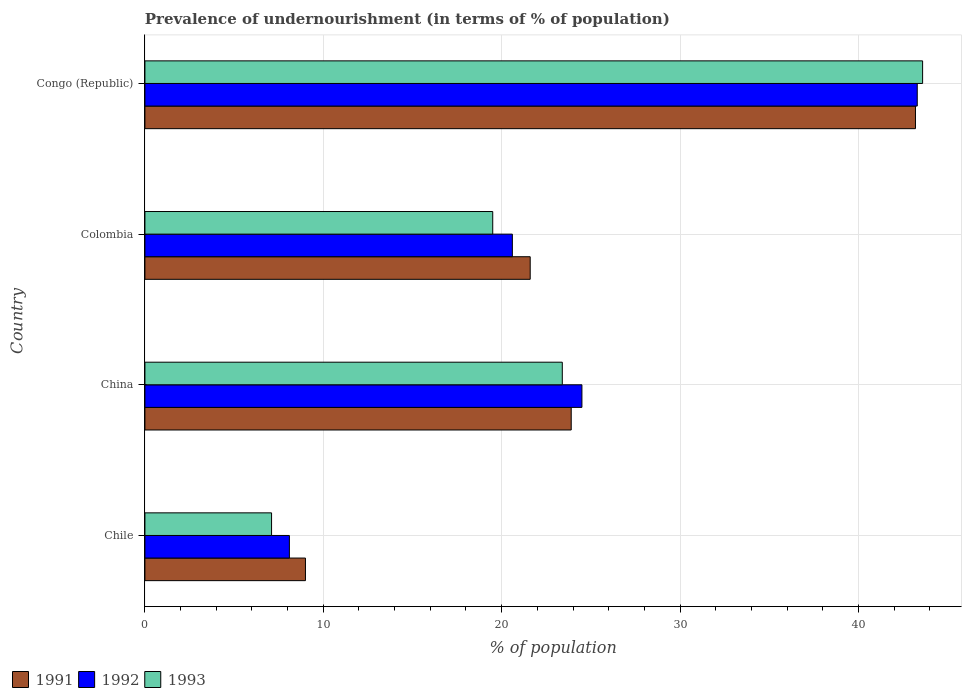How many different coloured bars are there?
Your answer should be very brief. 3. Are the number of bars on each tick of the Y-axis equal?
Provide a short and direct response. Yes. How many bars are there on the 2nd tick from the top?
Keep it short and to the point. 3. In how many cases, is the number of bars for a given country not equal to the number of legend labels?
Keep it short and to the point. 0. What is the percentage of undernourished population in 1993 in China?
Provide a short and direct response. 23.4. Across all countries, what is the maximum percentage of undernourished population in 1992?
Offer a terse response. 43.3. Across all countries, what is the minimum percentage of undernourished population in 1992?
Make the answer very short. 8.1. In which country was the percentage of undernourished population in 1991 maximum?
Your response must be concise. Congo (Republic). What is the total percentage of undernourished population in 1991 in the graph?
Your answer should be compact. 97.7. What is the difference between the percentage of undernourished population in 1993 in China and that in Congo (Republic)?
Provide a succinct answer. -20.2. What is the difference between the percentage of undernourished population in 1991 in China and the percentage of undernourished population in 1993 in Chile?
Provide a succinct answer. 16.8. What is the average percentage of undernourished population in 1993 per country?
Provide a short and direct response. 23.4. What is the difference between the percentage of undernourished population in 1992 and percentage of undernourished population in 1993 in Congo (Republic)?
Provide a succinct answer. -0.3. In how many countries, is the percentage of undernourished population in 1993 greater than 6 %?
Ensure brevity in your answer.  4. What is the ratio of the percentage of undernourished population in 1992 in China to that in Colombia?
Offer a very short reply. 1.19. Is the percentage of undernourished population in 1992 in China less than that in Colombia?
Provide a short and direct response. No. Is the difference between the percentage of undernourished population in 1992 in China and Congo (Republic) greater than the difference between the percentage of undernourished population in 1993 in China and Congo (Republic)?
Give a very brief answer. Yes. What is the difference between the highest and the second highest percentage of undernourished population in 1992?
Make the answer very short. 18.8. What is the difference between the highest and the lowest percentage of undernourished population in 1993?
Ensure brevity in your answer.  36.5. In how many countries, is the percentage of undernourished population in 1991 greater than the average percentage of undernourished population in 1991 taken over all countries?
Provide a short and direct response. 1. What does the 1st bar from the top in Congo (Republic) represents?
Keep it short and to the point. 1993. What does the 3rd bar from the bottom in China represents?
Your response must be concise. 1993. Is it the case that in every country, the sum of the percentage of undernourished population in 1992 and percentage of undernourished population in 1993 is greater than the percentage of undernourished population in 1991?
Your answer should be very brief. Yes. Are all the bars in the graph horizontal?
Make the answer very short. Yes. How many countries are there in the graph?
Ensure brevity in your answer.  4. What is the difference between two consecutive major ticks on the X-axis?
Offer a very short reply. 10. Does the graph contain any zero values?
Provide a short and direct response. No. Does the graph contain grids?
Your answer should be compact. Yes. Where does the legend appear in the graph?
Your response must be concise. Bottom left. How many legend labels are there?
Your answer should be very brief. 3. How are the legend labels stacked?
Make the answer very short. Horizontal. What is the title of the graph?
Provide a succinct answer. Prevalence of undernourishment (in terms of % of population). Does "1961" appear as one of the legend labels in the graph?
Provide a short and direct response. No. What is the label or title of the X-axis?
Give a very brief answer. % of population. What is the % of population in 1991 in Chile?
Your answer should be very brief. 9. What is the % of population of 1992 in Chile?
Give a very brief answer. 8.1. What is the % of population of 1993 in Chile?
Provide a short and direct response. 7.1. What is the % of population in 1991 in China?
Offer a very short reply. 23.9. What is the % of population in 1993 in China?
Offer a terse response. 23.4. What is the % of population of 1991 in Colombia?
Your response must be concise. 21.6. What is the % of population in 1992 in Colombia?
Make the answer very short. 20.6. What is the % of population of 1991 in Congo (Republic)?
Give a very brief answer. 43.2. What is the % of population of 1992 in Congo (Republic)?
Your answer should be very brief. 43.3. What is the % of population in 1993 in Congo (Republic)?
Provide a succinct answer. 43.6. Across all countries, what is the maximum % of population of 1991?
Offer a very short reply. 43.2. Across all countries, what is the maximum % of population in 1992?
Your answer should be very brief. 43.3. Across all countries, what is the maximum % of population of 1993?
Offer a very short reply. 43.6. Across all countries, what is the minimum % of population in 1992?
Keep it short and to the point. 8.1. What is the total % of population of 1991 in the graph?
Provide a succinct answer. 97.7. What is the total % of population of 1992 in the graph?
Your answer should be very brief. 96.5. What is the total % of population in 1993 in the graph?
Your response must be concise. 93.6. What is the difference between the % of population of 1991 in Chile and that in China?
Your response must be concise. -14.9. What is the difference between the % of population in 1992 in Chile and that in China?
Your answer should be compact. -16.4. What is the difference between the % of population in 1993 in Chile and that in China?
Keep it short and to the point. -16.3. What is the difference between the % of population of 1991 in Chile and that in Colombia?
Keep it short and to the point. -12.6. What is the difference between the % of population of 1992 in Chile and that in Colombia?
Provide a short and direct response. -12.5. What is the difference between the % of population of 1993 in Chile and that in Colombia?
Provide a short and direct response. -12.4. What is the difference between the % of population in 1991 in Chile and that in Congo (Republic)?
Provide a succinct answer. -34.2. What is the difference between the % of population of 1992 in Chile and that in Congo (Republic)?
Offer a very short reply. -35.2. What is the difference between the % of population of 1993 in Chile and that in Congo (Republic)?
Your response must be concise. -36.5. What is the difference between the % of population of 1991 in China and that in Colombia?
Offer a very short reply. 2.3. What is the difference between the % of population in 1992 in China and that in Colombia?
Ensure brevity in your answer.  3.9. What is the difference between the % of population of 1993 in China and that in Colombia?
Provide a succinct answer. 3.9. What is the difference between the % of population of 1991 in China and that in Congo (Republic)?
Your answer should be compact. -19.3. What is the difference between the % of population in 1992 in China and that in Congo (Republic)?
Provide a succinct answer. -18.8. What is the difference between the % of population of 1993 in China and that in Congo (Republic)?
Provide a succinct answer. -20.2. What is the difference between the % of population of 1991 in Colombia and that in Congo (Republic)?
Make the answer very short. -21.6. What is the difference between the % of population in 1992 in Colombia and that in Congo (Republic)?
Give a very brief answer. -22.7. What is the difference between the % of population of 1993 in Colombia and that in Congo (Republic)?
Give a very brief answer. -24.1. What is the difference between the % of population of 1991 in Chile and the % of population of 1992 in China?
Your answer should be compact. -15.5. What is the difference between the % of population of 1991 in Chile and the % of population of 1993 in China?
Give a very brief answer. -14.4. What is the difference between the % of population in 1992 in Chile and the % of population in 1993 in China?
Your answer should be very brief. -15.3. What is the difference between the % of population of 1991 in Chile and the % of population of 1992 in Colombia?
Your answer should be compact. -11.6. What is the difference between the % of population of 1992 in Chile and the % of population of 1993 in Colombia?
Make the answer very short. -11.4. What is the difference between the % of population of 1991 in Chile and the % of population of 1992 in Congo (Republic)?
Your answer should be very brief. -34.3. What is the difference between the % of population of 1991 in Chile and the % of population of 1993 in Congo (Republic)?
Offer a very short reply. -34.6. What is the difference between the % of population of 1992 in Chile and the % of population of 1993 in Congo (Republic)?
Provide a succinct answer. -35.5. What is the difference between the % of population of 1991 in China and the % of population of 1993 in Colombia?
Offer a terse response. 4.4. What is the difference between the % of population in 1991 in China and the % of population in 1992 in Congo (Republic)?
Ensure brevity in your answer.  -19.4. What is the difference between the % of population in 1991 in China and the % of population in 1993 in Congo (Republic)?
Provide a short and direct response. -19.7. What is the difference between the % of population in 1992 in China and the % of population in 1993 in Congo (Republic)?
Provide a short and direct response. -19.1. What is the difference between the % of population in 1991 in Colombia and the % of population in 1992 in Congo (Republic)?
Your answer should be very brief. -21.7. What is the difference between the % of population of 1991 in Colombia and the % of population of 1993 in Congo (Republic)?
Your answer should be very brief. -22. What is the difference between the % of population in 1992 in Colombia and the % of population in 1993 in Congo (Republic)?
Keep it short and to the point. -23. What is the average % of population of 1991 per country?
Offer a very short reply. 24.43. What is the average % of population in 1992 per country?
Your answer should be very brief. 24.12. What is the average % of population in 1993 per country?
Provide a succinct answer. 23.4. What is the difference between the % of population in 1991 and % of population in 1992 in Chile?
Keep it short and to the point. 0.9. What is the difference between the % of population in 1992 and % of population in 1993 in Chile?
Provide a short and direct response. 1. What is the difference between the % of population in 1991 and % of population in 1993 in China?
Your answer should be very brief. 0.5. What is the difference between the % of population of 1992 and % of population of 1993 in China?
Provide a short and direct response. 1.1. What is the difference between the % of population of 1991 and % of population of 1993 in Colombia?
Offer a very short reply. 2.1. What is the difference between the % of population in 1992 and % of population in 1993 in Congo (Republic)?
Your response must be concise. -0.3. What is the ratio of the % of population of 1991 in Chile to that in China?
Make the answer very short. 0.38. What is the ratio of the % of population in 1992 in Chile to that in China?
Offer a terse response. 0.33. What is the ratio of the % of population of 1993 in Chile to that in China?
Make the answer very short. 0.3. What is the ratio of the % of population in 1991 in Chile to that in Colombia?
Ensure brevity in your answer.  0.42. What is the ratio of the % of population of 1992 in Chile to that in Colombia?
Offer a very short reply. 0.39. What is the ratio of the % of population in 1993 in Chile to that in Colombia?
Offer a terse response. 0.36. What is the ratio of the % of population in 1991 in Chile to that in Congo (Republic)?
Ensure brevity in your answer.  0.21. What is the ratio of the % of population in 1992 in Chile to that in Congo (Republic)?
Your response must be concise. 0.19. What is the ratio of the % of population in 1993 in Chile to that in Congo (Republic)?
Offer a terse response. 0.16. What is the ratio of the % of population of 1991 in China to that in Colombia?
Make the answer very short. 1.11. What is the ratio of the % of population of 1992 in China to that in Colombia?
Offer a terse response. 1.19. What is the ratio of the % of population of 1993 in China to that in Colombia?
Give a very brief answer. 1.2. What is the ratio of the % of population in 1991 in China to that in Congo (Republic)?
Keep it short and to the point. 0.55. What is the ratio of the % of population of 1992 in China to that in Congo (Republic)?
Keep it short and to the point. 0.57. What is the ratio of the % of population of 1993 in China to that in Congo (Republic)?
Make the answer very short. 0.54. What is the ratio of the % of population of 1991 in Colombia to that in Congo (Republic)?
Your answer should be very brief. 0.5. What is the ratio of the % of population in 1992 in Colombia to that in Congo (Republic)?
Ensure brevity in your answer.  0.48. What is the ratio of the % of population in 1993 in Colombia to that in Congo (Republic)?
Provide a short and direct response. 0.45. What is the difference between the highest and the second highest % of population in 1991?
Your answer should be very brief. 19.3. What is the difference between the highest and the second highest % of population of 1992?
Your answer should be compact. 18.8. What is the difference between the highest and the second highest % of population of 1993?
Give a very brief answer. 20.2. What is the difference between the highest and the lowest % of population in 1991?
Offer a very short reply. 34.2. What is the difference between the highest and the lowest % of population in 1992?
Keep it short and to the point. 35.2. What is the difference between the highest and the lowest % of population of 1993?
Offer a terse response. 36.5. 